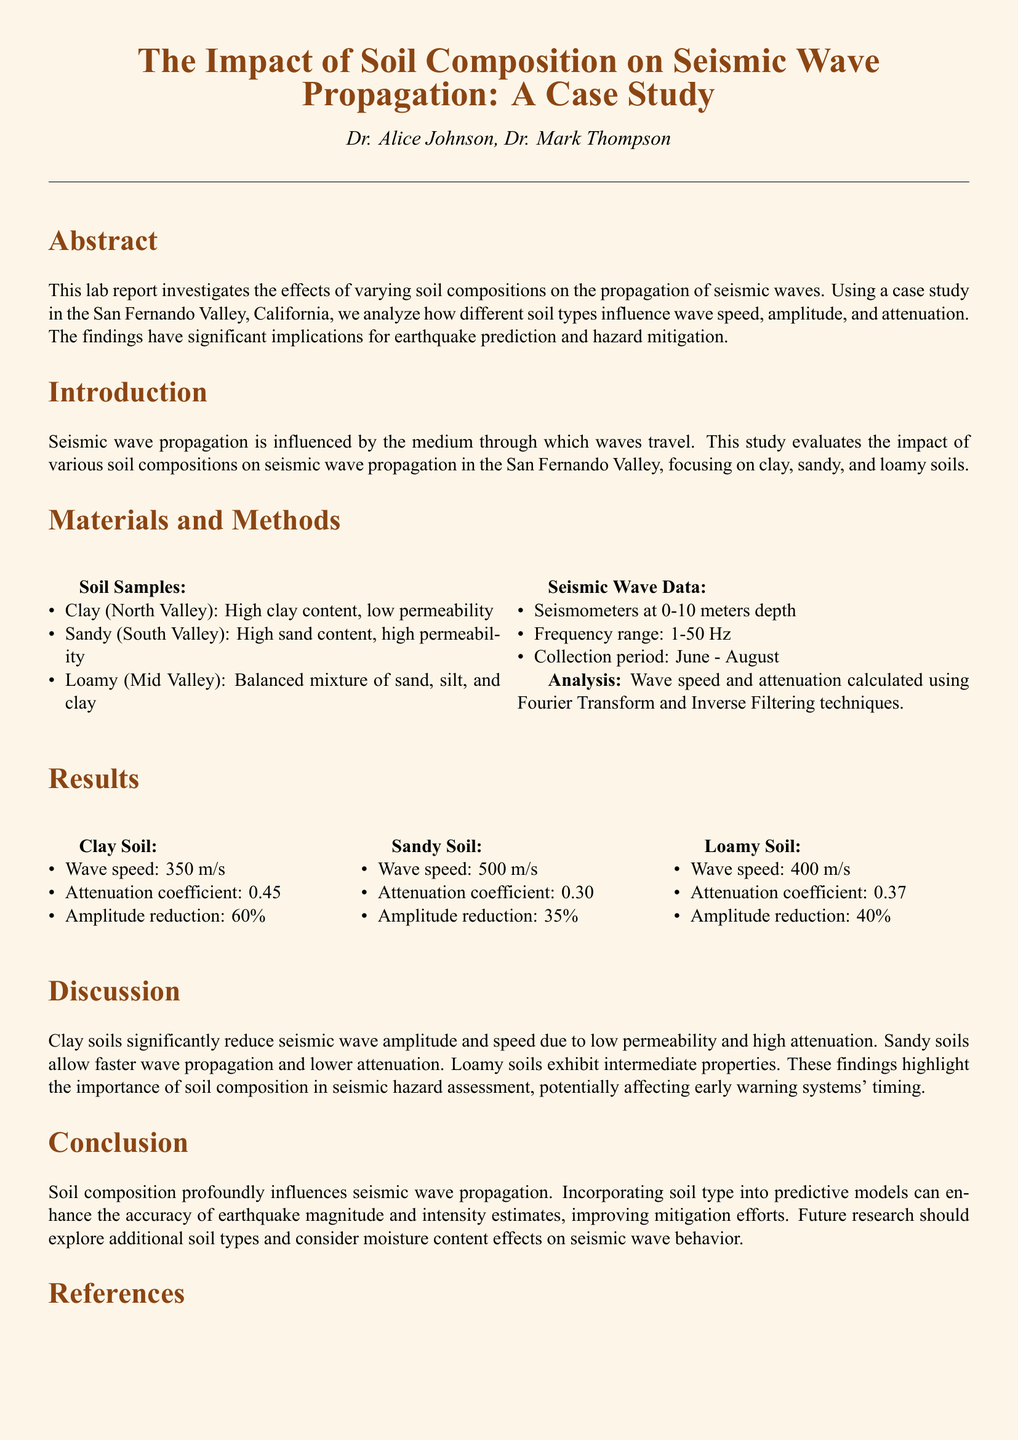What is the main focus of the study? The main focus is to investigate the effects of varying soil compositions on the propagation of seismic waves.
Answer: effects of varying soil compositions on the propagation of seismic waves What is the wave speed in sandy soil? The wave speed in sandy soil is presented in the Results section.
Answer: 500 m/s What was the collection period for the seismic data? The collection period is detailed in the Materials and Methods section.
Answer: June - August Which type of soil had the highest attenuation coefficient? The highest attenuation coefficient can be found in the Results section for clay soil.
Answer: 0.45 What are the implications of the findings? The implications are discussed in the Discussion section, focusing on earthquake prediction and hazard mitigation.
Answer: earthquake prediction and hazard mitigation What type of analysis was used to calculate wave speed and attenuation? The analysis method is outlined in the Materials and Methods section.
Answer: Fourier Transform and Inverse Filtering techniques Which soil exhibits intermediate properties in terms of seismic wave propagation? The intermediate properties of soil types are indicated in the Results and Discussion sections.
Answer: Loamy soil What improvements are suggested for future research? Suggestions for future research are discussed in the Conclusion section.
Answer: explore additional soil types and consider moisture content effects 